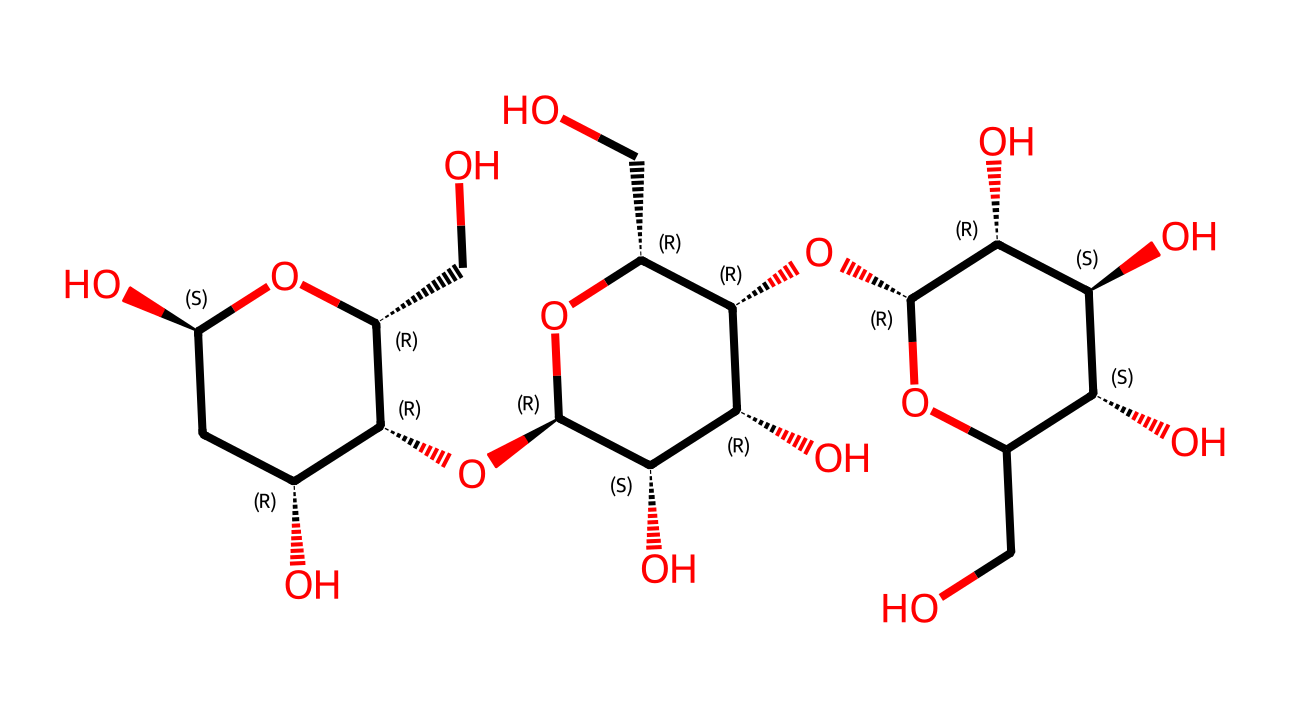What is the molecular weight of cellulose? To find the molecular weight of cellulose, we add the atomic weights of all atoms present in the structure. Each carbon, hydrogen, and oxygen atom contributes a specific amount to the total molecular weight. From the structure, we can deduce the total number of each type of atom and calculate the molecular weight.
Answer: 162.14 g/mol How many carbon atoms are present in this cellulose molecule? By analyzing the SMILES representation, we can count the number of 'C' characters, signifying each carbon atom in the structure. Careful counting reveals there are multiple carbon atoms organized in the cyclic structure.
Answer: 6 What type of glycosidic linkage is found in cellulose? Cellulose contains β-1,4-glycosidic linkages, which are identified by the orientation of the hydroxyl groups and the position of the connecting bonds between the monosaccharide units.
Answer: β-1,4-glycosidic How many hydroxyl groups are present in the structure? The presence of hydroxyl groups (–OH) can be counted directly from the SMILES notation. Each appearance of 'O' connected with a hydrogen corresponds to a hydroxyl group. The visual assessment leads to the conclusion regarding the number of such groups present.
Answer: 3 Is cellulose a soluble or insoluble fiber? Cellulose is classified as an insoluble fiber due to its structural composition and the strong hydrogen bonding between the chains, which makes it unable to dissolve in water.
Answer: insoluble Does this cellulose structure indicate branching? Upon analysis of the chemical structure, it becomes clear that cellulose does not exhibit branching, as all monomeric units are linked in a linear fashion without any side chains.
Answer: no 